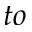<formula> <loc_0><loc_0><loc_500><loc_500>t o</formula> 